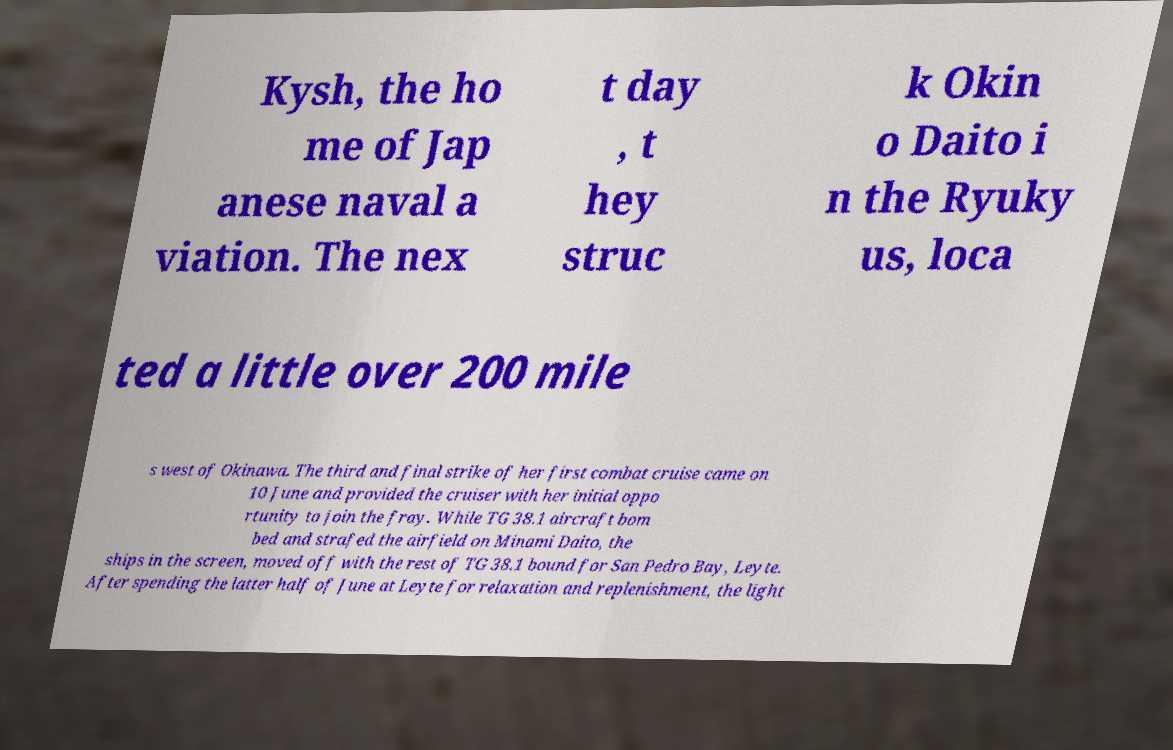Please identify and transcribe the text found in this image. Kysh, the ho me of Jap anese naval a viation. The nex t day , t hey struc k Okin o Daito i n the Ryuky us, loca ted a little over 200 mile s west of Okinawa. The third and final strike of her first combat cruise came on 10 June and provided the cruiser with her initial oppo rtunity to join the fray. While TG 38.1 aircraft bom bed and strafed the airfield on Minami Daito, the ships in the screen, moved off with the rest of TG 38.1 bound for San Pedro Bay, Leyte. After spending the latter half of June at Leyte for relaxation and replenishment, the light 